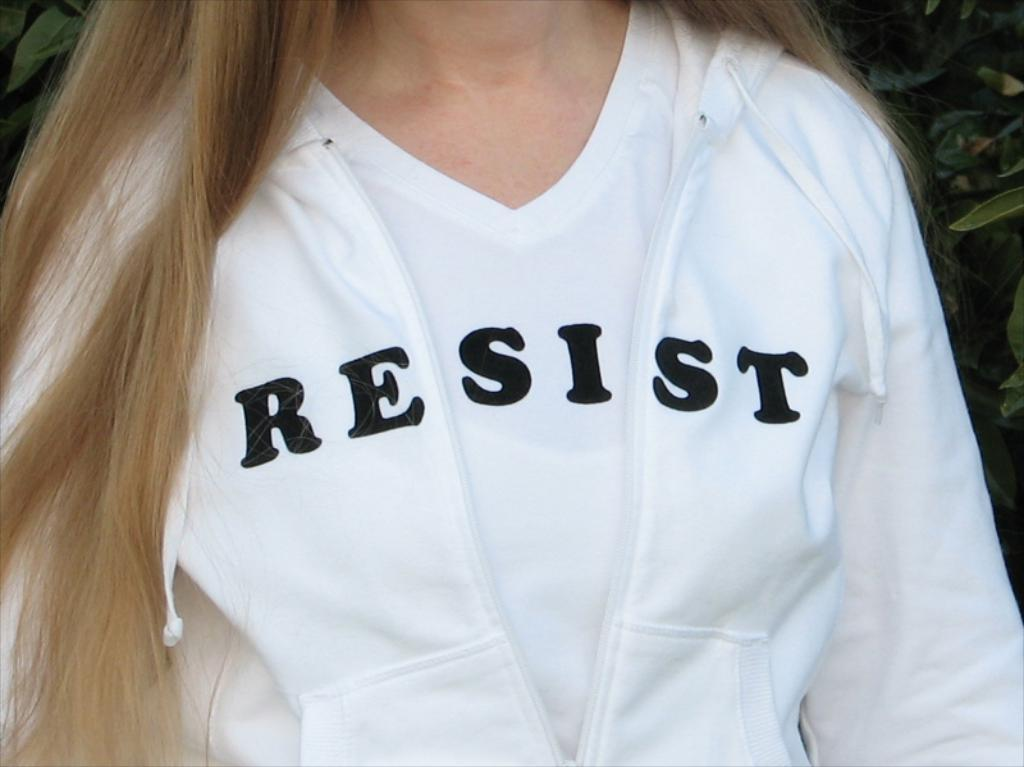<image>
Write a terse but informative summary of the picture. A woman is wearing a white jacket and shirt, combined together they spell the word resist. 